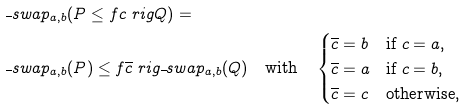Convert formula to latex. <formula><loc_0><loc_0><loc_500><loc_500>& \overline { \ } s w a p _ { a , b } ( P \leq f c \ r i g Q ) = \\ & \overline { \ } s w a p _ { a , b } ( P ) \leq f \overline { c } \ r i g \overline { \ } s w a p _ { a , b } ( Q ) \quad \text {with} \quad \begin{cases} \overline { c } = b & \text {if } c = a , \\ \overline { c } = a & \text {if } c = b , \\ \overline { c } = c & \text {otherwise} , \end{cases}</formula> 